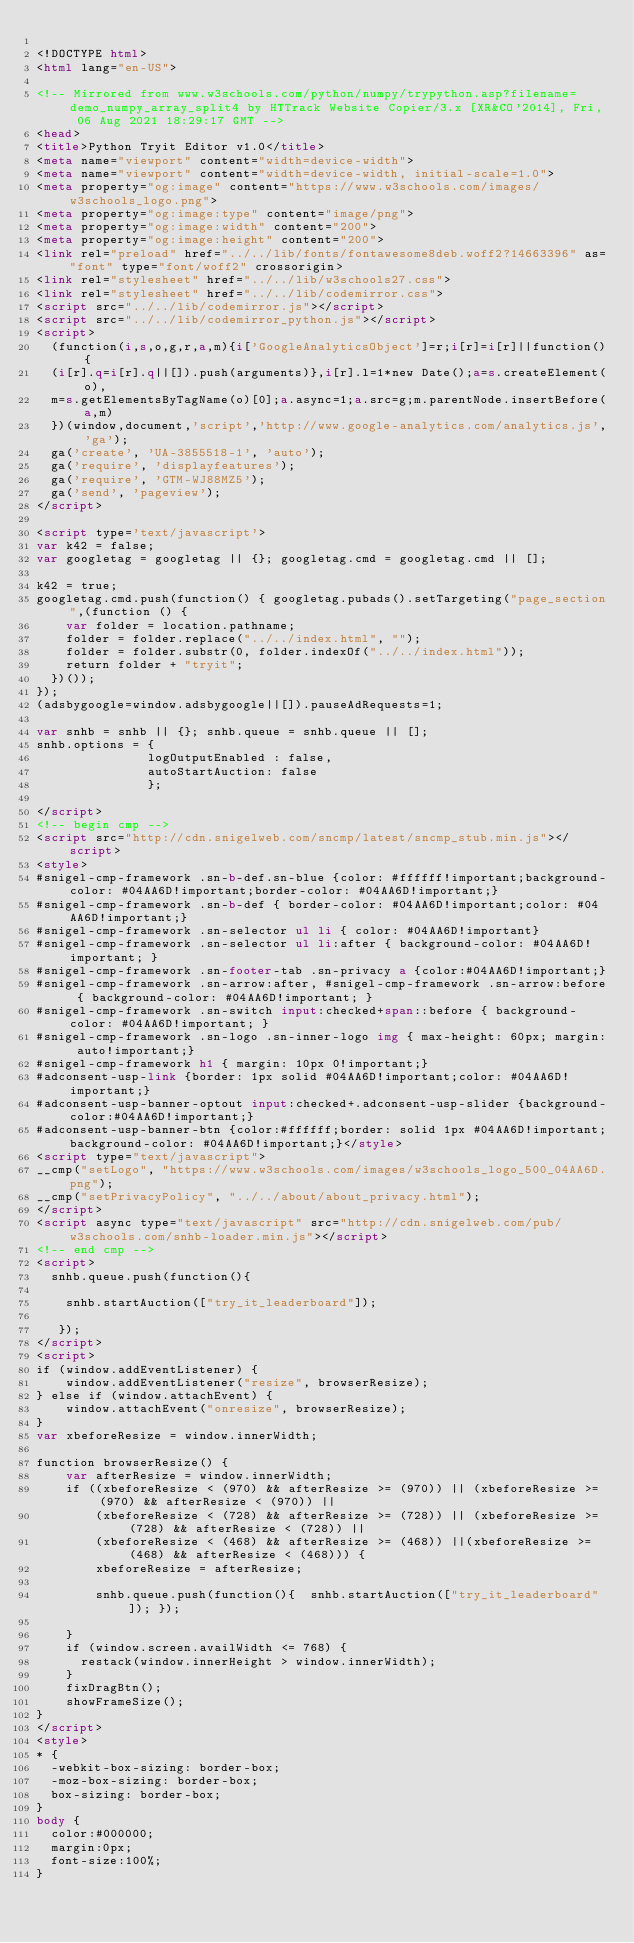Convert code to text. <code><loc_0><loc_0><loc_500><loc_500><_HTML_>
<!DOCTYPE html>
<html lang="en-US">

<!-- Mirrored from www.w3schools.com/python/numpy/trypython.asp?filename=demo_numpy_array_split4 by HTTrack Website Copier/3.x [XR&CO'2014], Fri, 06 Aug 2021 18:29:17 GMT -->
<head>
<title>Python Tryit Editor v1.0</title>
<meta name="viewport" content="width=device-width">
<meta name="viewport" content="width=device-width, initial-scale=1.0">
<meta property="og:image" content="https://www.w3schools.com/images/w3schools_logo.png">
<meta property="og:image:type" content="image/png">
<meta property="og:image:width" content="200">
<meta property="og:image:height" content="200">
<link rel="preload" href="../../lib/fonts/fontawesome8deb.woff2?14663396" as="font" type="font/woff2" crossorigin> 
<link rel="stylesheet" href="../../lib/w3schools27.css">
<link rel="stylesheet" href="../../lib/codemirror.css">
<script src="../../lib/codemirror.js"></script>
<script src="../../lib/codemirror_python.js"></script>
<script>
  (function(i,s,o,g,r,a,m){i['GoogleAnalyticsObject']=r;i[r]=i[r]||function(){
  (i[r].q=i[r].q||[]).push(arguments)},i[r].l=1*new Date();a=s.createElement(o),
  m=s.getElementsByTagName(o)[0];a.async=1;a.src=g;m.parentNode.insertBefore(a,m)
  })(window,document,'script','http://www.google-analytics.com/analytics.js','ga');
  ga('create', 'UA-3855518-1', 'auto');
  ga('require', 'displayfeatures');
  ga('require', 'GTM-WJ88MZ5');
  ga('send', 'pageview');
</script>

<script type='text/javascript'>
var k42 = false;
var googletag = googletag || {}; googletag.cmd = googletag.cmd || [];

k42 = true;
googletag.cmd.push(function() { googletag.pubads().setTargeting("page_section",(function () {
    var folder = location.pathname;
    folder = folder.replace("../../index.html", "");
    folder = folder.substr(0, folder.indexOf("../../index.html"));
    return folder + "tryit";
  })());
});
(adsbygoogle=window.adsbygoogle||[]).pauseAdRequests=1;

var snhb = snhb || {}; snhb.queue = snhb.queue || [];
snhb.options = {
               logOutputEnabled : false,
               autoStartAuction: false
               };

</script>
<!-- begin cmp -->
<script src="http://cdn.snigelweb.com/sncmp/latest/sncmp_stub.min.js"></script>
<style>
#snigel-cmp-framework .sn-b-def.sn-blue {color: #ffffff!important;background-color: #04AA6D!important;border-color: #04AA6D!important;}
#snigel-cmp-framework .sn-b-def { border-color: #04AA6D!important;color: #04AA6D!important;}
#snigel-cmp-framework .sn-selector ul li { color: #04AA6D!important}
#snigel-cmp-framework .sn-selector ul li:after { background-color: #04AA6D!important; }
#snigel-cmp-framework .sn-footer-tab .sn-privacy a {color:#04AA6D!important;}
#snigel-cmp-framework .sn-arrow:after, #snigel-cmp-framework .sn-arrow:before { background-color: #04AA6D!important; }
#snigel-cmp-framework .sn-switch input:checked+span::before { background-color: #04AA6D!important; }
#snigel-cmp-framework .sn-logo .sn-inner-logo img { max-height: 60px; margin: auto!important;}
#snigel-cmp-framework h1 { margin: 10px 0!important;}
#adconsent-usp-link {border: 1px solid #04AA6D!important;color: #04AA6D!important;}
#adconsent-usp-banner-optout input:checked+.adconsent-usp-slider {background-color:#04AA6D!important;}
#adconsent-usp-banner-btn {color:#ffffff;border: solid 1px #04AA6D!important;background-color: #04AA6D!important;}</style>
<script type="text/javascript">
__cmp("setLogo", "https://www.w3schools.com/images/w3schools_logo_500_04AA6D.png");
__cmp("setPrivacyPolicy", "../../about/about_privacy.html");
</script>
<script async type="text/javascript" src="http://cdn.snigelweb.com/pub/w3schools.com/snhb-loader.min.js"></script>
<!-- end cmp -->
<script>
  snhb.queue.push(function(){

    snhb.startAuction(["try_it_leaderboard"]);

   });
</script>
<script>
if (window.addEventListener) {              
    window.addEventListener("resize", browserResize);
} else if (window.attachEvent) {                 
    window.attachEvent("onresize", browserResize);
}
var xbeforeResize = window.innerWidth;

function browserResize() {
    var afterResize = window.innerWidth;
    if ((xbeforeResize < (970) && afterResize >= (970)) || (xbeforeResize >= (970) && afterResize < (970)) ||
        (xbeforeResize < (728) && afterResize >= (728)) || (xbeforeResize >= (728) && afterResize < (728)) ||
        (xbeforeResize < (468) && afterResize >= (468)) ||(xbeforeResize >= (468) && afterResize < (468))) {
        xbeforeResize = afterResize;
        
        snhb.queue.push(function(){  snhb.startAuction(["try_it_leaderboard"]); });
         
    }
    if (window.screen.availWidth <= 768) {
      restack(window.innerHeight > window.innerWidth);
    }
    fixDragBtn();
    showFrameSize();    
}
</script>
<style>
* {
  -webkit-box-sizing: border-box;
  -moz-box-sizing: border-box;
  box-sizing: border-box;
}
body {
  color:#000000;
  margin:0px;
  font-size:100%;
}</code> 